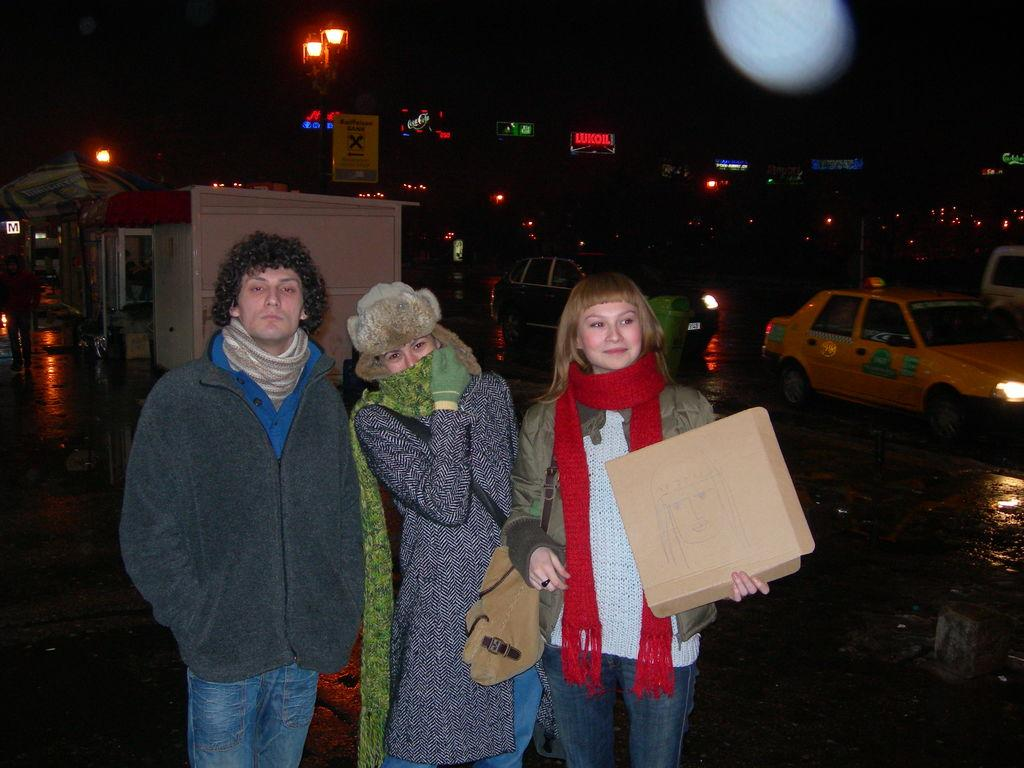How many people are in the image? There is a group of people in the image, but the exact number cannot be determined from the provided facts. What can be seen in the background of the image? In the background of the image, there are vehicles, lights, sign boards, and hoardings. What might the sign boards and hoardings be advertising or displaying? The sign boards and hoardings in the background of the image might be displaying advertisements, directions, or information. What type of ball is being used by the boys in the image? There is no mention of a ball or boys in the image, so it is not possible to answer this question. 